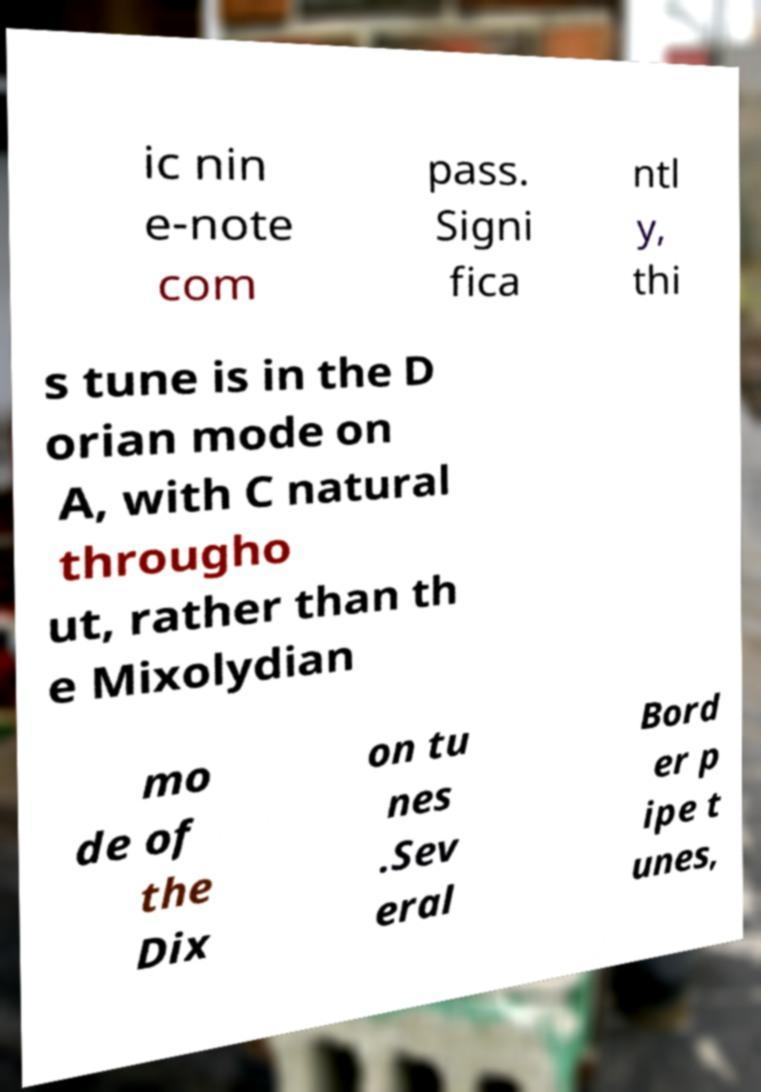What messages or text are displayed in this image? I need them in a readable, typed format. ic nin e-note com pass. Signi fica ntl y, thi s tune is in the D orian mode on A, with C natural througho ut, rather than th e Mixolydian mo de of the Dix on tu nes .Sev eral Bord er p ipe t unes, 